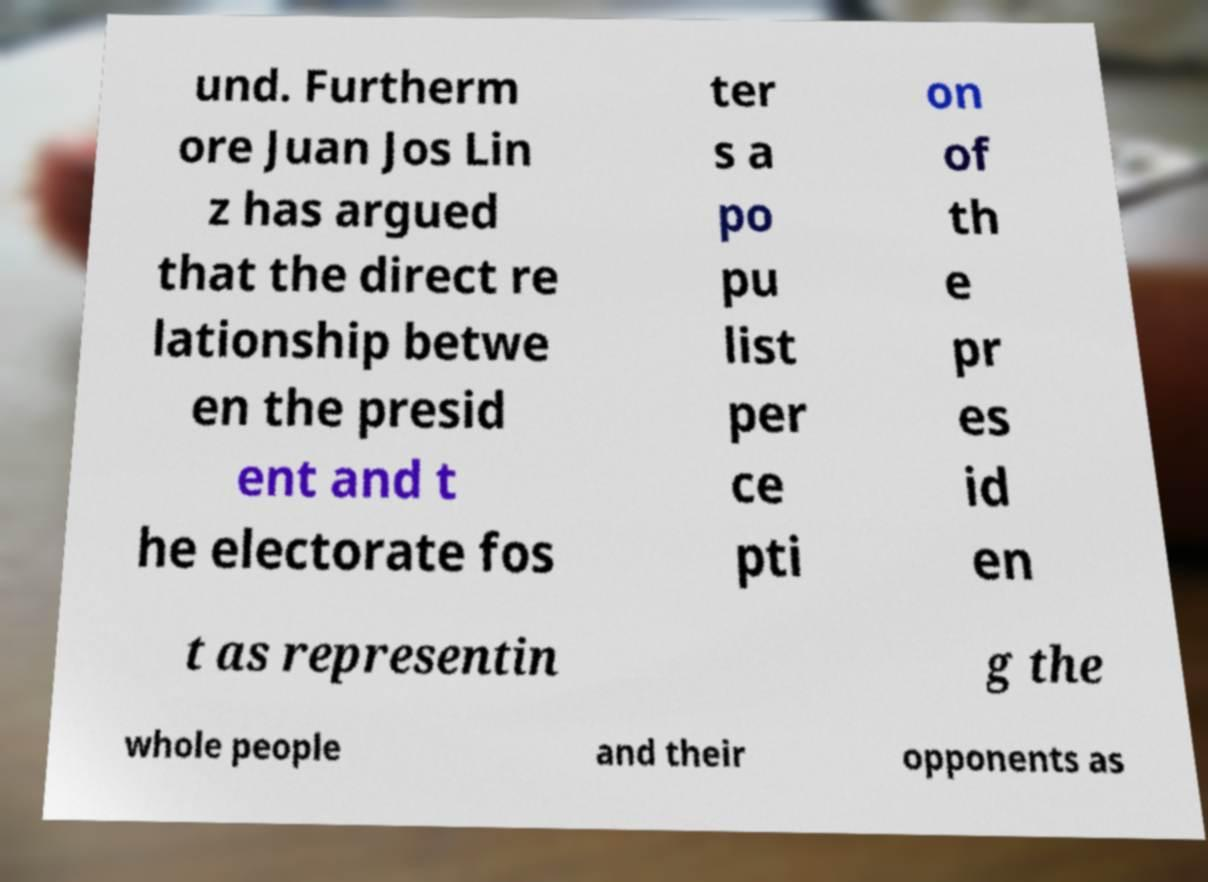Could you assist in decoding the text presented in this image and type it out clearly? und. Furtherm ore Juan Jos Lin z has argued that the direct re lationship betwe en the presid ent and t he electorate fos ter s a po pu list per ce pti on of th e pr es id en t as representin g the whole people and their opponents as 